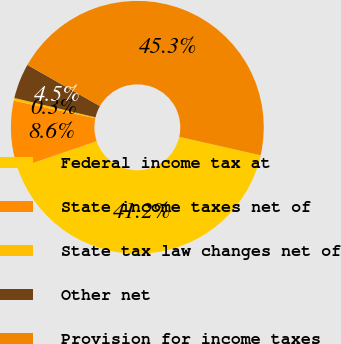<chart> <loc_0><loc_0><loc_500><loc_500><pie_chart><fcel>Federal income tax at<fcel>State income taxes net of<fcel>State tax law changes net of<fcel>Other net<fcel>Provision for income taxes<nl><fcel>41.21%<fcel>8.62%<fcel>0.35%<fcel>4.49%<fcel>45.34%<nl></chart> 